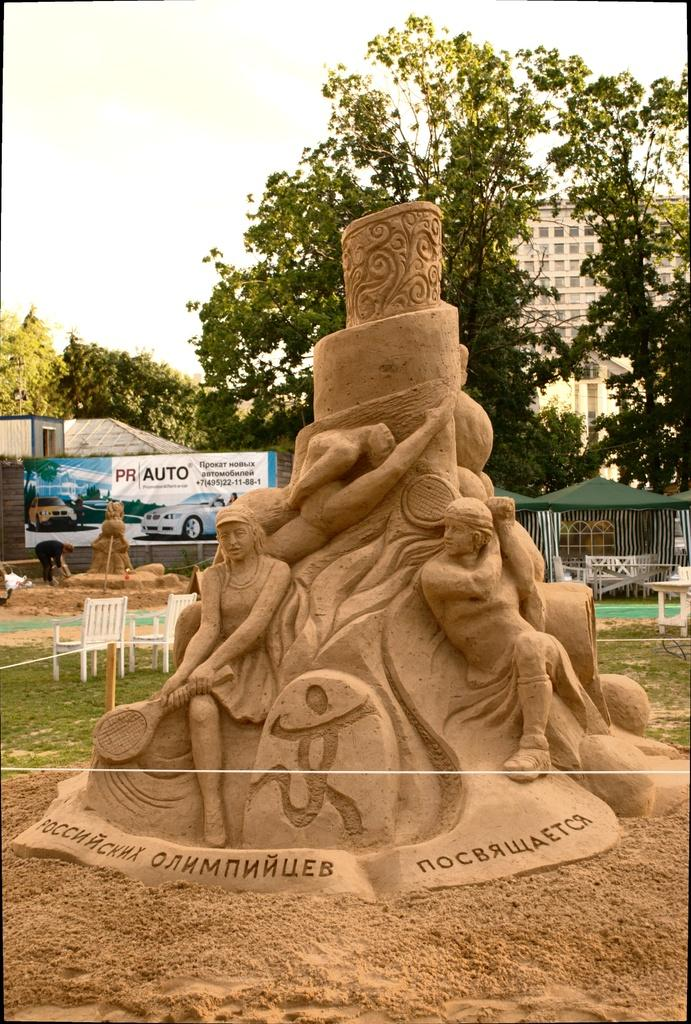What is the main subject in the middle of the image? There is sand art in the middle of the image. What surrounds the sand art? There is a fence around the sand art. What can be seen in the background of the image? In the background of the image, there is a hoarding, trees, chairs, tents, buildings, windows, and the sky. How many necks can be seen in the image? There are no necks visible in the image. What type of knife is being used to increase the size of the sand art? There is no knife present in the image, and the size of the sand art is not being increased. 